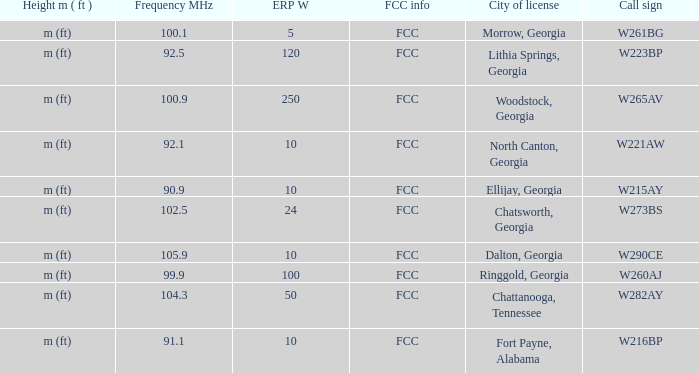Which City of license has a Frequency MHz smaller than 100.9, and a ERP W larger than 100? Lithia Springs, Georgia. 